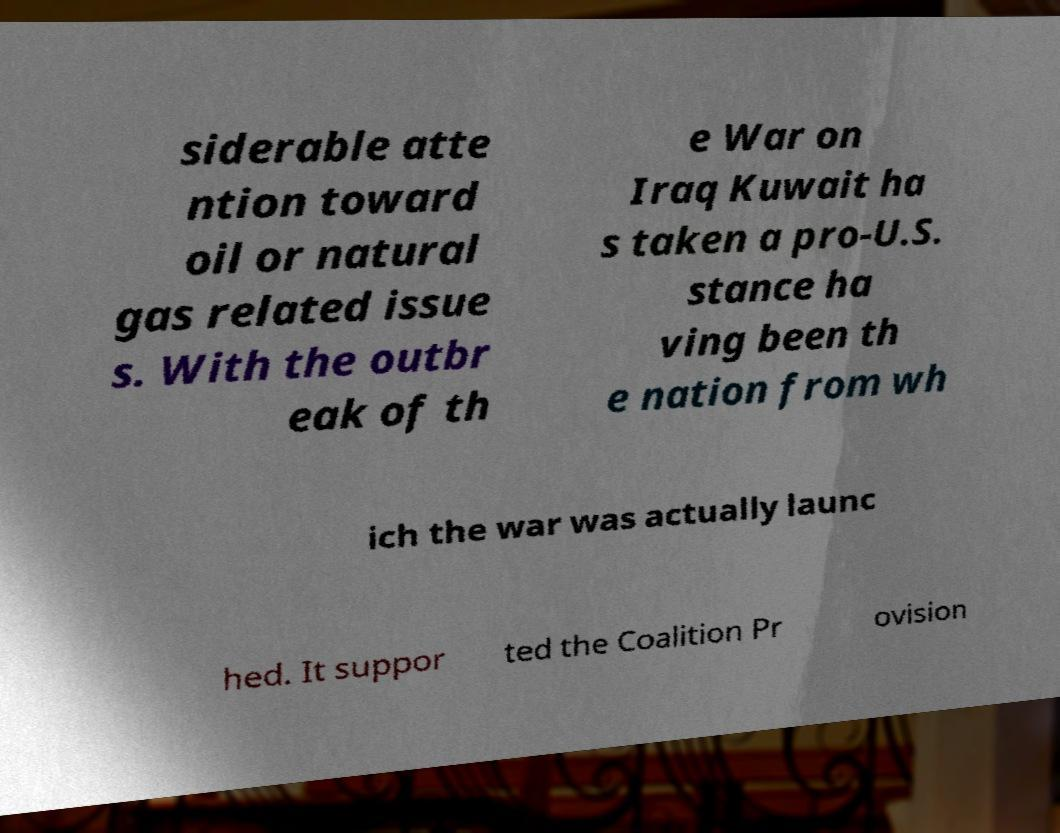What messages or text are displayed in this image? I need them in a readable, typed format. siderable atte ntion toward oil or natural gas related issue s. With the outbr eak of th e War on Iraq Kuwait ha s taken a pro-U.S. stance ha ving been th e nation from wh ich the war was actually launc hed. It suppor ted the Coalition Pr ovision 